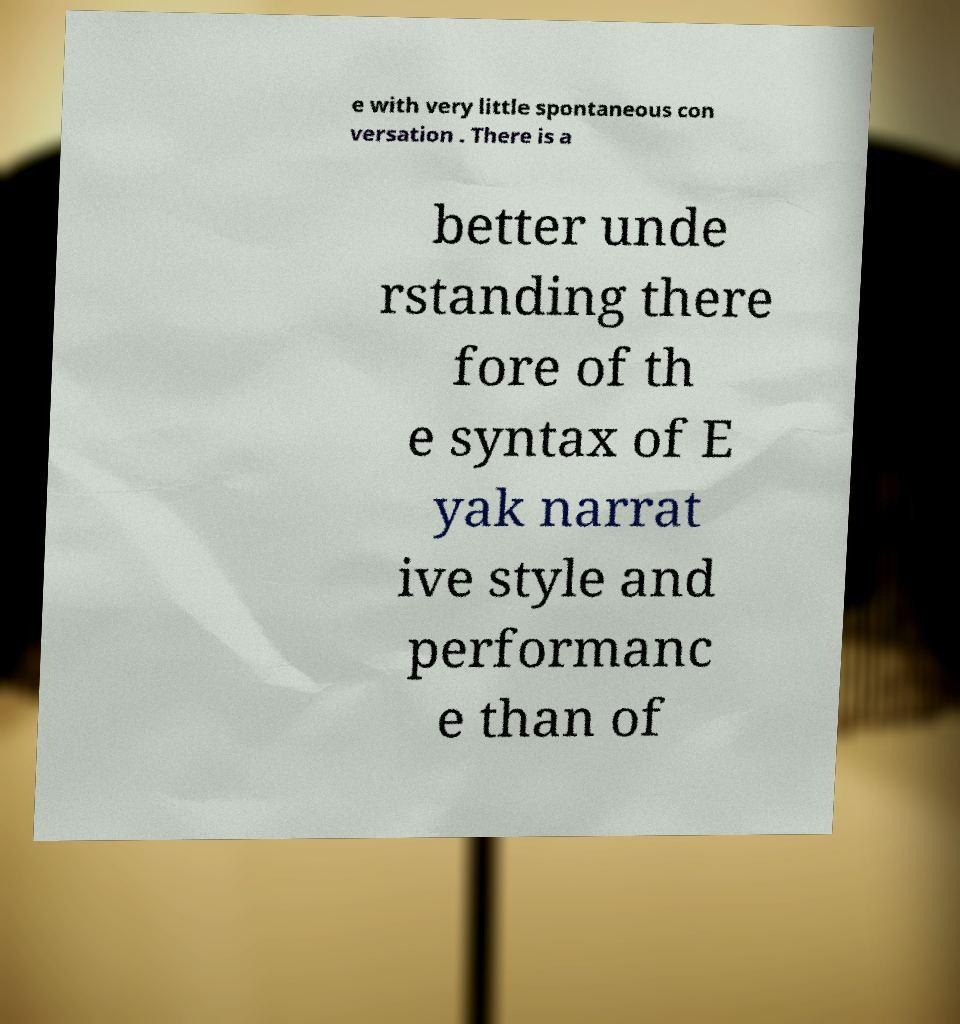For documentation purposes, I need the text within this image transcribed. Could you provide that? e with very little spontaneous con versation . There is a better unde rstanding there fore of th e syntax of E yak narrat ive style and performanc e than of 